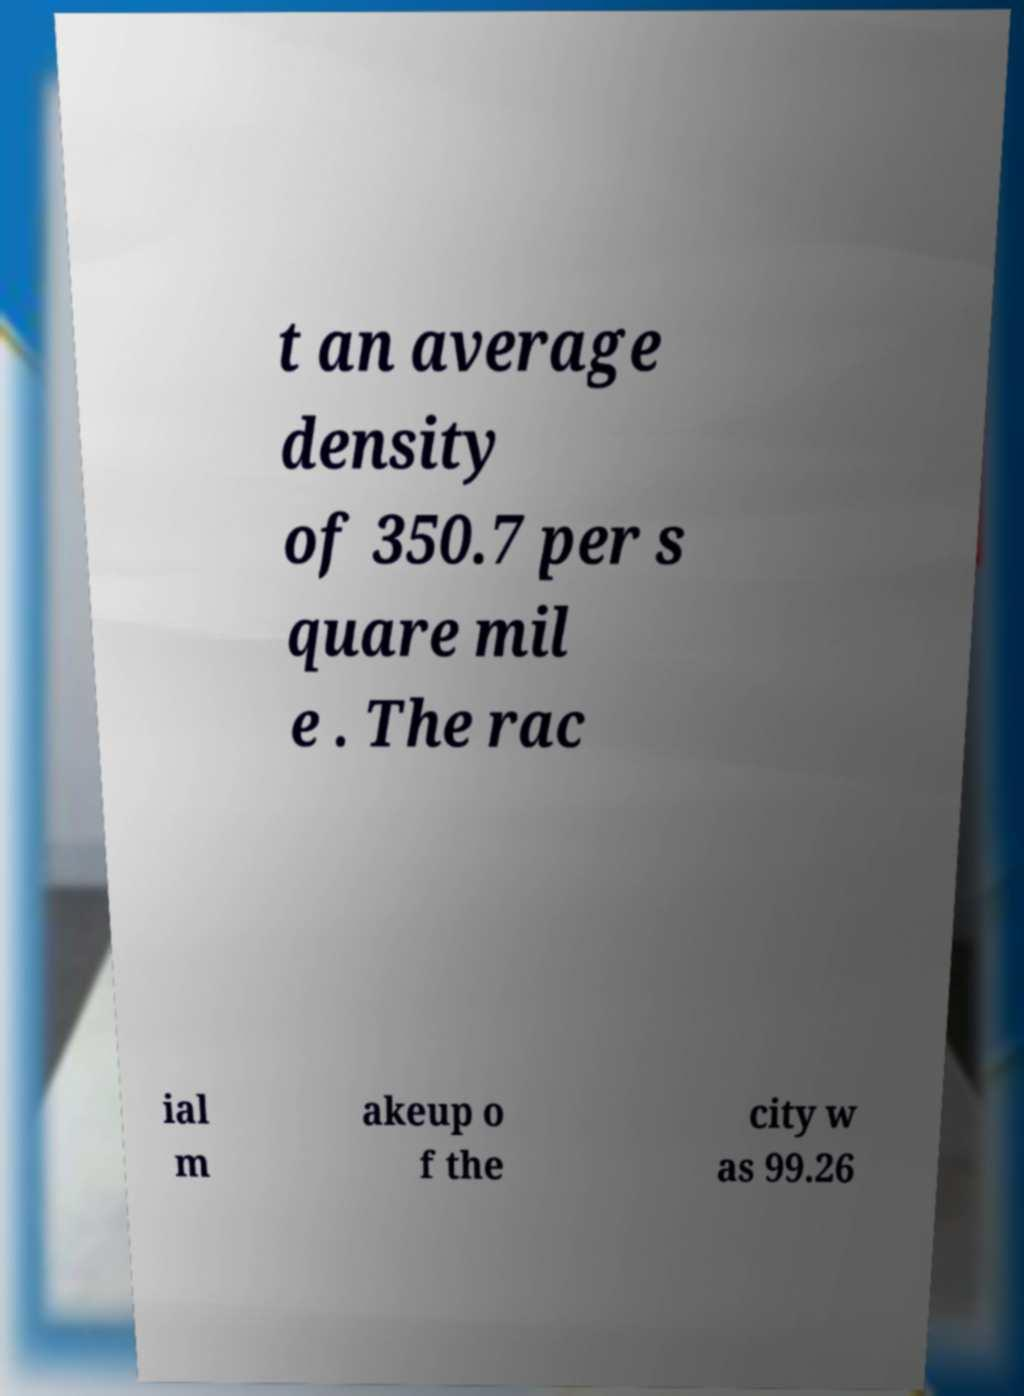Please identify and transcribe the text found in this image. t an average density of 350.7 per s quare mil e . The rac ial m akeup o f the city w as 99.26 